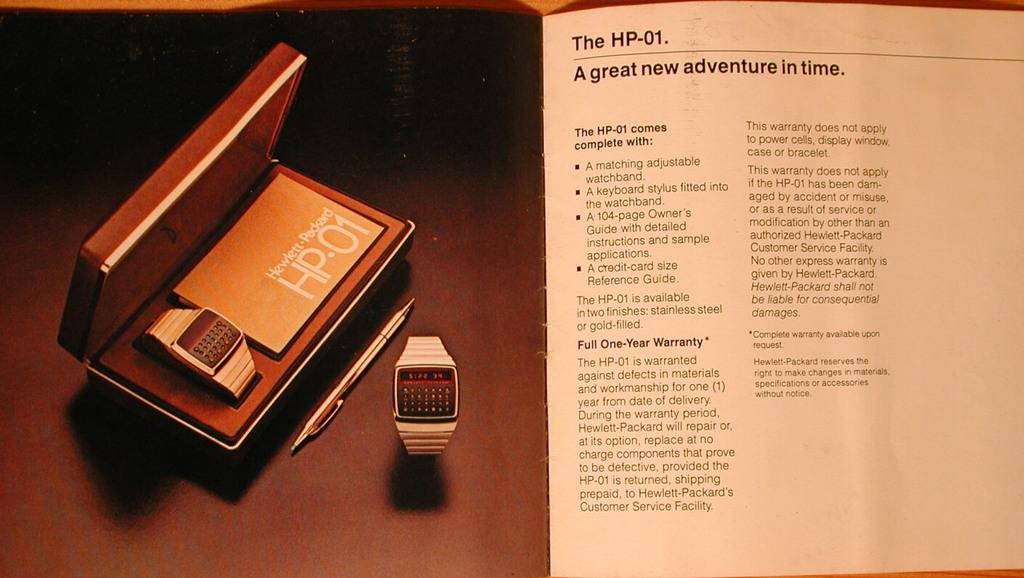<image>
Give a short and clear explanation of the subsequent image. A magazine ad about the HP-01 wrist keypad. 